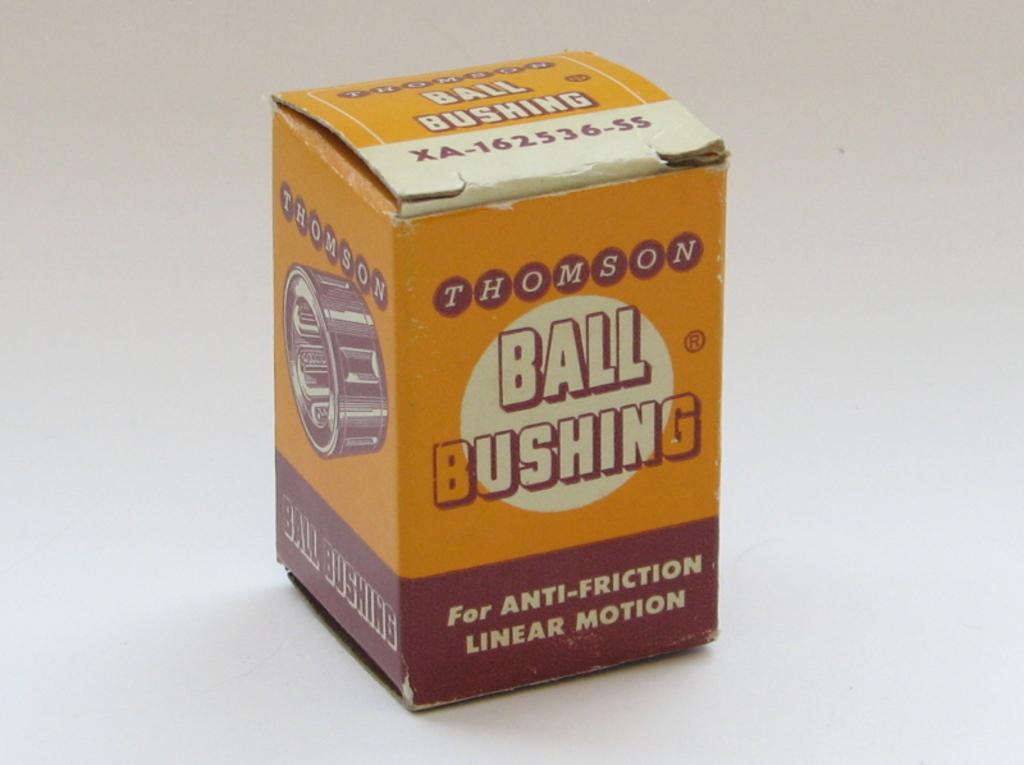What is this product for?
Your answer should be compact. Anti-friction linear motion. What is the creator of this product?
Make the answer very short. Thomson. 